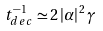<formula> <loc_0><loc_0><loc_500><loc_500>t _ { d e c } ^ { - 1 } \simeq 2 \left | \alpha \right | ^ { 2 } \gamma</formula> 